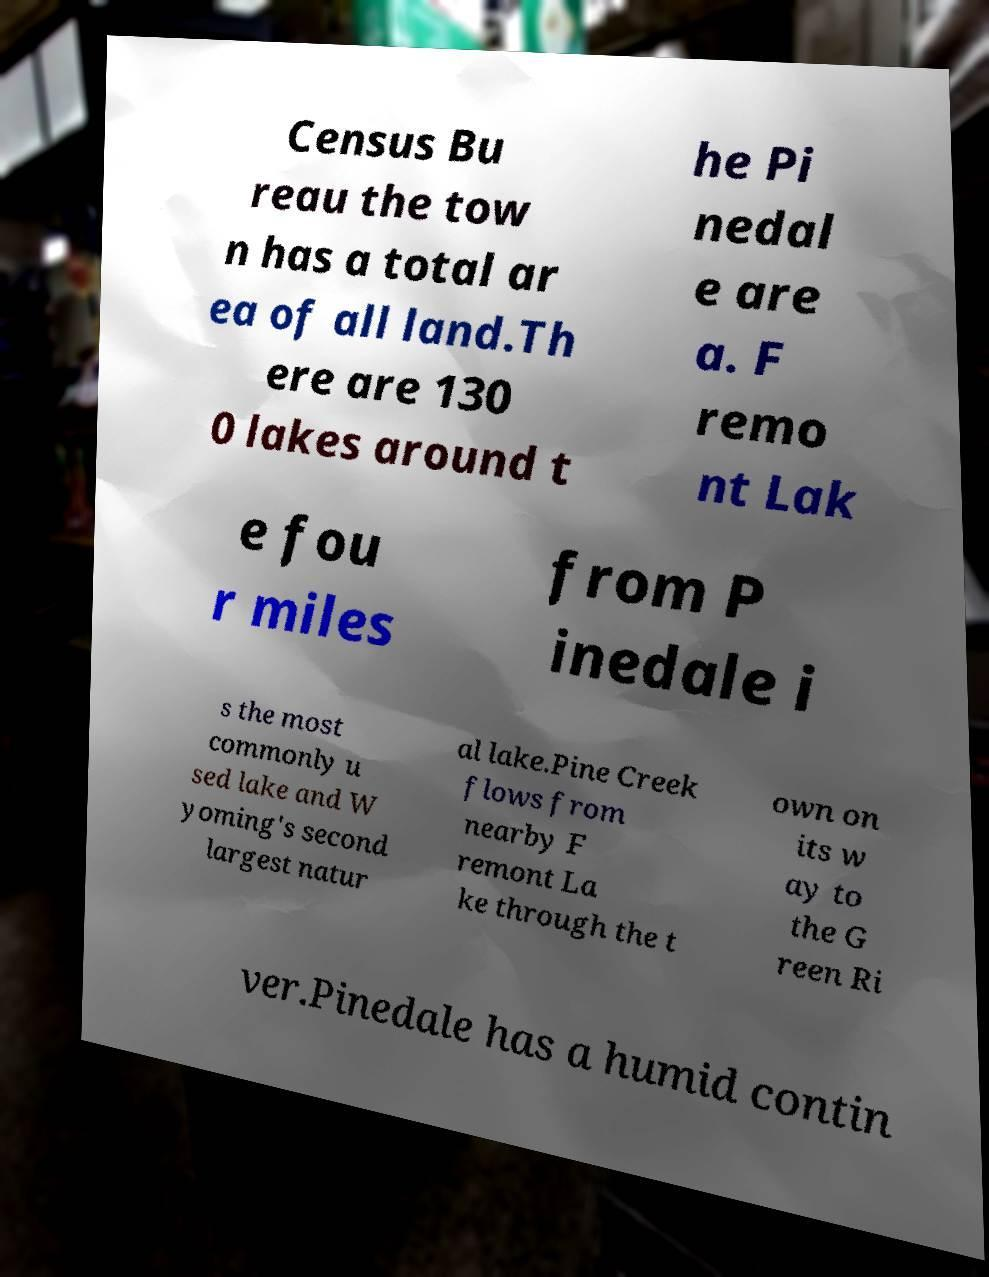For documentation purposes, I need the text within this image transcribed. Could you provide that? Census Bu reau the tow n has a total ar ea of all land.Th ere are 130 0 lakes around t he Pi nedal e are a. F remo nt Lak e fou r miles from P inedale i s the most commonly u sed lake and W yoming's second largest natur al lake.Pine Creek flows from nearby F remont La ke through the t own on its w ay to the G reen Ri ver.Pinedale has a humid contin 